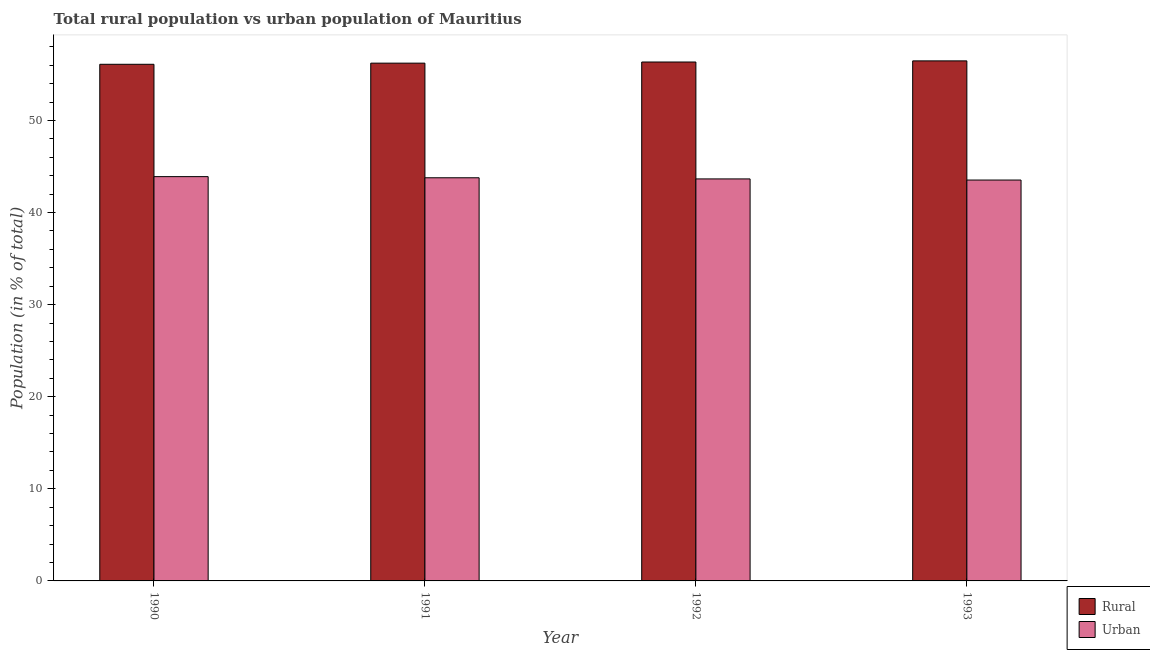How many different coloured bars are there?
Your answer should be very brief. 2. How many groups of bars are there?
Provide a short and direct response. 4. Are the number of bars per tick equal to the number of legend labels?
Offer a very short reply. Yes. What is the rural population in 1990?
Your response must be concise. 56.1. Across all years, what is the maximum rural population?
Give a very brief answer. 56.47. Across all years, what is the minimum urban population?
Provide a succinct answer. 43.53. In which year was the urban population minimum?
Make the answer very short. 1993. What is the total urban population in the graph?
Your answer should be very brief. 174.86. What is the difference between the rural population in 1990 and that in 1992?
Your answer should be very brief. -0.25. What is the difference between the urban population in 1992 and the rural population in 1991?
Provide a short and direct response. -0.12. What is the average rural population per year?
Offer a terse response. 56.29. What is the ratio of the urban population in 1991 to that in 1993?
Keep it short and to the point. 1.01. What is the difference between the highest and the second highest urban population?
Give a very brief answer. 0.12. What is the difference between the highest and the lowest urban population?
Provide a succinct answer. 0.37. What does the 2nd bar from the left in 1993 represents?
Provide a succinct answer. Urban. What does the 1st bar from the right in 1991 represents?
Offer a terse response. Urban. How many years are there in the graph?
Your response must be concise. 4. What is the difference between two consecutive major ticks on the Y-axis?
Offer a very short reply. 10. Are the values on the major ticks of Y-axis written in scientific E-notation?
Offer a terse response. No. Does the graph contain grids?
Keep it short and to the point. No. How are the legend labels stacked?
Give a very brief answer. Vertical. What is the title of the graph?
Your answer should be compact. Total rural population vs urban population of Mauritius. Does "State government" appear as one of the legend labels in the graph?
Your response must be concise. No. What is the label or title of the X-axis?
Your answer should be compact. Year. What is the label or title of the Y-axis?
Your answer should be very brief. Population (in % of total). What is the Population (in % of total) of Rural in 1990?
Provide a short and direct response. 56.1. What is the Population (in % of total) of Urban in 1990?
Give a very brief answer. 43.9. What is the Population (in % of total) of Rural in 1991?
Your answer should be compact. 56.22. What is the Population (in % of total) of Urban in 1991?
Ensure brevity in your answer.  43.78. What is the Population (in % of total) in Rural in 1992?
Offer a very short reply. 56.35. What is the Population (in % of total) of Urban in 1992?
Give a very brief answer. 43.65. What is the Population (in % of total) in Rural in 1993?
Provide a short and direct response. 56.47. What is the Population (in % of total) in Urban in 1993?
Give a very brief answer. 43.53. Across all years, what is the maximum Population (in % of total) of Rural?
Offer a terse response. 56.47. Across all years, what is the maximum Population (in % of total) in Urban?
Give a very brief answer. 43.9. Across all years, what is the minimum Population (in % of total) in Rural?
Your answer should be compact. 56.1. Across all years, what is the minimum Population (in % of total) in Urban?
Your answer should be compact. 43.53. What is the total Population (in % of total) in Rural in the graph?
Your answer should be very brief. 225.14. What is the total Population (in % of total) of Urban in the graph?
Your answer should be compact. 174.86. What is the difference between the Population (in % of total) in Rural in 1990 and that in 1991?
Offer a very short reply. -0.12. What is the difference between the Population (in % of total) in Urban in 1990 and that in 1991?
Give a very brief answer. 0.12. What is the difference between the Population (in % of total) of Rural in 1990 and that in 1992?
Your answer should be very brief. -0.25. What is the difference between the Population (in % of total) in Urban in 1990 and that in 1992?
Give a very brief answer. 0.25. What is the difference between the Population (in % of total) of Rural in 1990 and that in 1993?
Provide a succinct answer. -0.37. What is the difference between the Population (in % of total) of Urban in 1990 and that in 1993?
Keep it short and to the point. 0.37. What is the difference between the Population (in % of total) of Rural in 1991 and that in 1992?
Offer a terse response. -0.12. What is the difference between the Population (in % of total) in Urban in 1991 and that in 1992?
Provide a short and direct response. 0.12. What is the difference between the Population (in % of total) of Rural in 1991 and that in 1993?
Ensure brevity in your answer.  -0.25. What is the difference between the Population (in % of total) of Urban in 1991 and that in 1993?
Offer a terse response. 0.25. What is the difference between the Population (in % of total) in Rural in 1992 and that in 1993?
Ensure brevity in your answer.  -0.12. What is the difference between the Population (in % of total) of Urban in 1992 and that in 1993?
Give a very brief answer. 0.12. What is the difference between the Population (in % of total) in Rural in 1990 and the Population (in % of total) in Urban in 1991?
Give a very brief answer. 12.32. What is the difference between the Population (in % of total) in Rural in 1990 and the Population (in % of total) in Urban in 1992?
Give a very brief answer. 12.45. What is the difference between the Population (in % of total) of Rural in 1990 and the Population (in % of total) of Urban in 1993?
Your answer should be very brief. 12.57. What is the difference between the Population (in % of total) of Rural in 1991 and the Population (in % of total) of Urban in 1992?
Offer a very short reply. 12.57. What is the difference between the Population (in % of total) in Rural in 1991 and the Population (in % of total) in Urban in 1993?
Your answer should be compact. 12.69. What is the difference between the Population (in % of total) in Rural in 1992 and the Population (in % of total) in Urban in 1993?
Give a very brief answer. 12.82. What is the average Population (in % of total) in Rural per year?
Offer a terse response. 56.28. What is the average Population (in % of total) in Urban per year?
Ensure brevity in your answer.  43.72. In the year 1991, what is the difference between the Population (in % of total) of Rural and Population (in % of total) of Urban?
Keep it short and to the point. 12.45. In the year 1992, what is the difference between the Population (in % of total) in Rural and Population (in % of total) in Urban?
Provide a succinct answer. 12.69. In the year 1993, what is the difference between the Population (in % of total) of Rural and Population (in % of total) of Urban?
Your answer should be very brief. 12.94. What is the ratio of the Population (in % of total) in Urban in 1990 to that in 1992?
Give a very brief answer. 1.01. What is the ratio of the Population (in % of total) of Urban in 1990 to that in 1993?
Provide a short and direct response. 1.01. What is the ratio of the Population (in % of total) of Rural in 1991 to that in 1992?
Your answer should be very brief. 1. What is the ratio of the Population (in % of total) in Urban in 1991 to that in 1992?
Provide a short and direct response. 1. What is the ratio of the Population (in % of total) of Rural in 1991 to that in 1993?
Keep it short and to the point. 1. What is the ratio of the Population (in % of total) of Rural in 1992 to that in 1993?
Keep it short and to the point. 1. What is the difference between the highest and the second highest Population (in % of total) of Rural?
Provide a short and direct response. 0.12. What is the difference between the highest and the second highest Population (in % of total) of Urban?
Keep it short and to the point. 0.12. What is the difference between the highest and the lowest Population (in % of total) in Rural?
Ensure brevity in your answer.  0.37. What is the difference between the highest and the lowest Population (in % of total) in Urban?
Your answer should be compact. 0.37. 